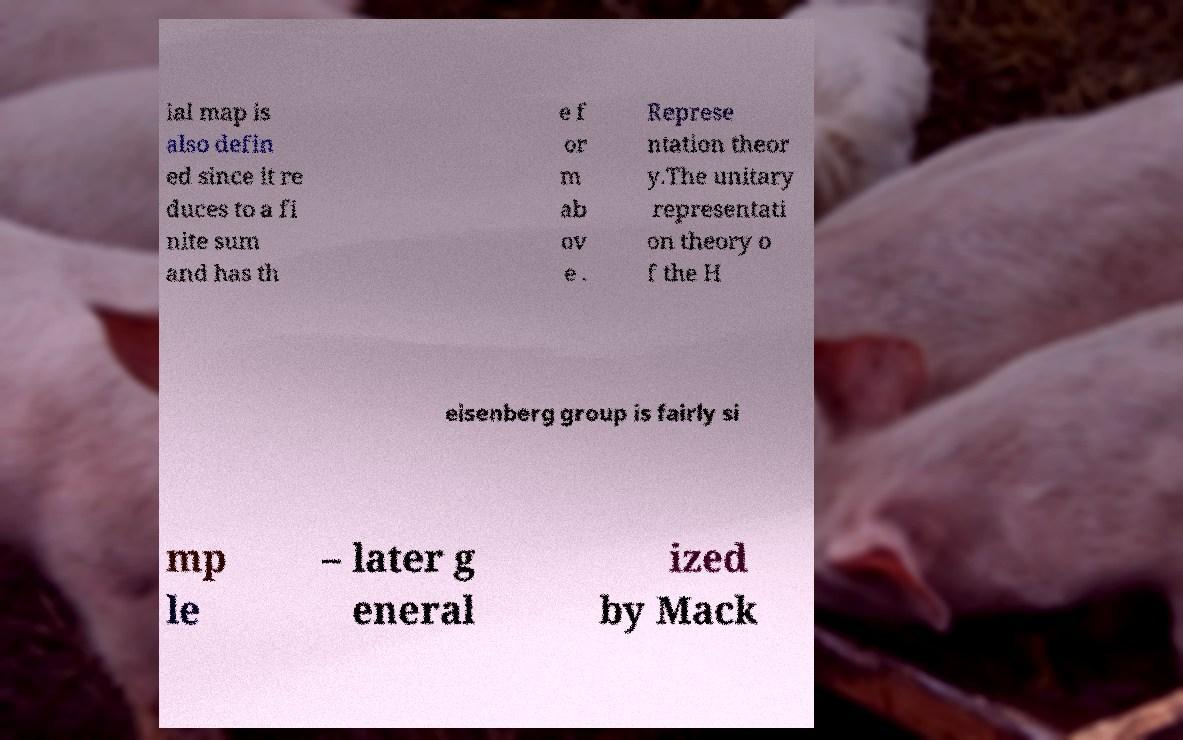I need the written content from this picture converted into text. Can you do that? ial map is also defin ed since it re duces to a fi nite sum and has th e f or m ab ov e . Represe ntation theor y.The unitary representati on theory o f the H eisenberg group is fairly si mp le – later g eneral ized by Mack 